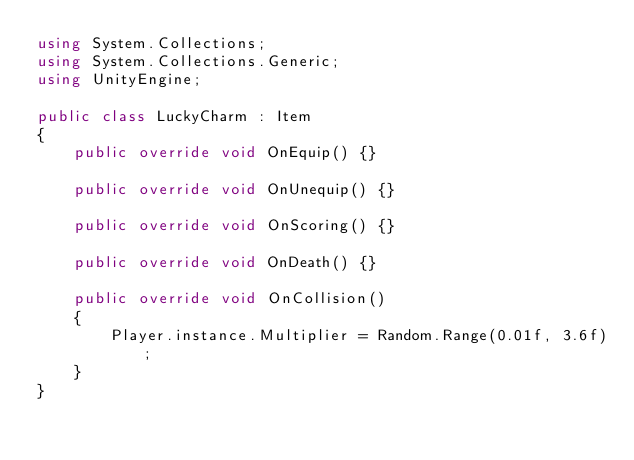<code> <loc_0><loc_0><loc_500><loc_500><_C#_>using System.Collections;
using System.Collections.Generic;
using UnityEngine;

public class LuckyCharm : Item
{
    public override void OnEquip() {}
    
    public override void OnUnequip() {}

    public override void OnScoring() {}

    public override void OnDeath() {}

    public override void OnCollision()
    {
        Player.instance.Multiplier = Random.Range(0.01f, 3.6f);
    }
}</code> 